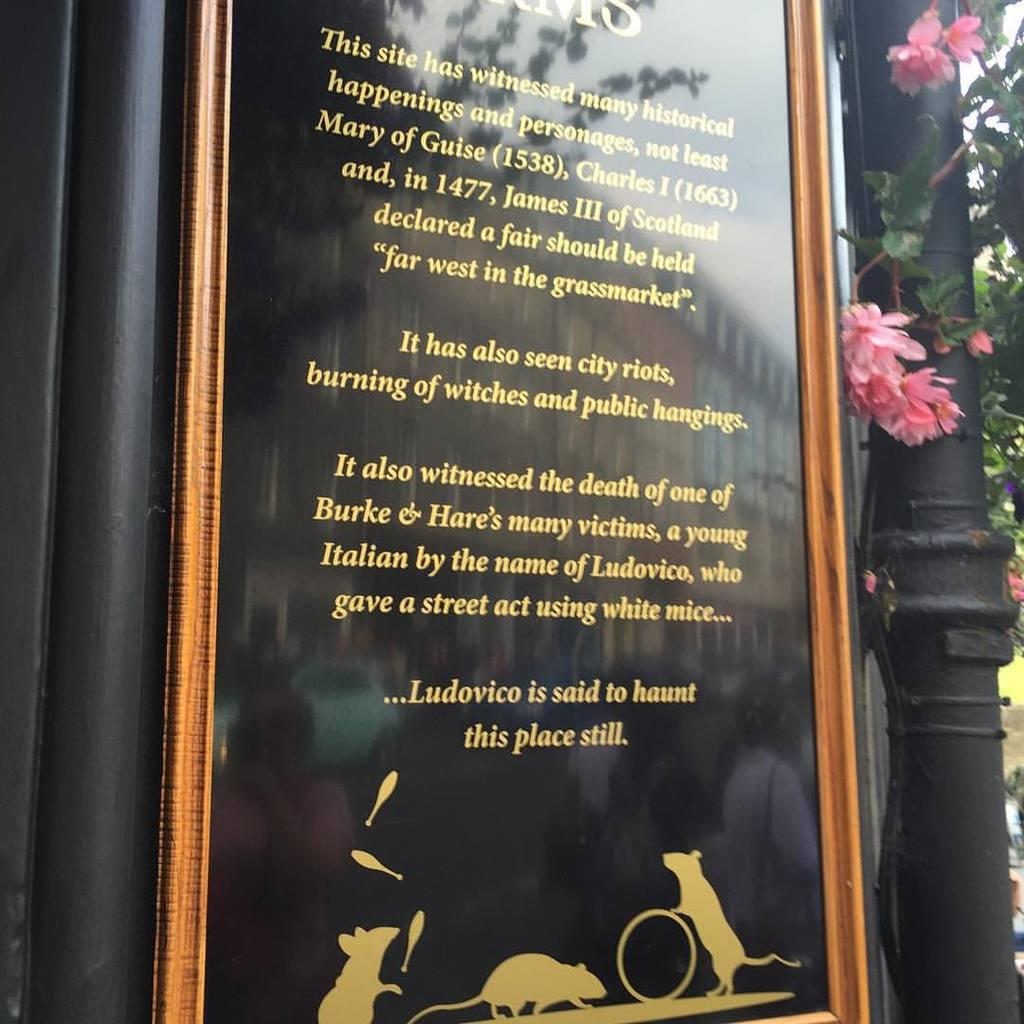What is placed on the wall in the center of the image? There is a frame placed on the wall in the center of the image. What can be seen in the background of the image? There is a pole and a tree visible in the background of the image. What is growing on the tree? Flowers are present on the tree. What type of wrench is being used to remove the flowers from the tree in the image? There is no wrench present in the image, and the flowers are not being removed from the tree. 